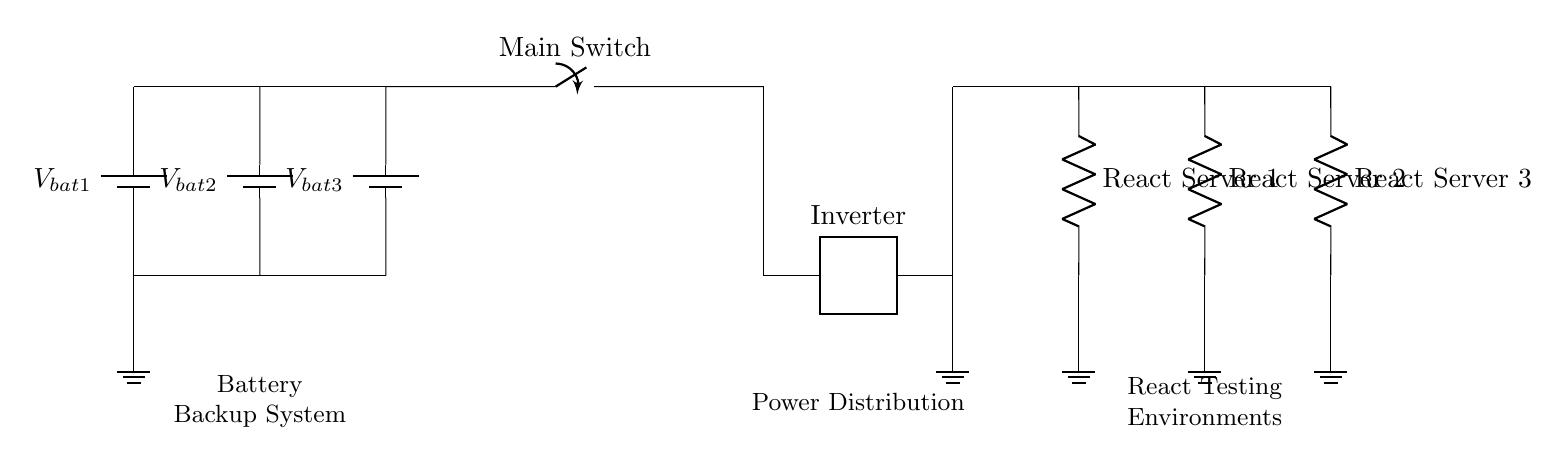What is the type of circuit shown? The circuit is a parallel circuit because the batteries are connected side-by-side, allowing multiple paths for current to flow.
Answer: Parallel circuit How many batteries are in the system? The circuit shows three batteries connected in parallel. Each battery is represented individually in the diagram.
Answer: Three What is the function of the inverter? The inverter converts the direct current from the batteries into alternating current, which is necessary for the server racks to operate, as they typically use AC power.
Answer: Converts DC to AC What is the role of the main switch? The main switch controls the flow of power from the battery backup system to the inverter, allowing the user to easily connect or disconnect power to the entire system.
Answer: Power control Which component represents the React server? The components labeled "React Server 1," "React Server 2," and "React Server 3" indicate the servers hosting the React testing environments in the circuit diagram.
Answer: React servers What happens if one battery fails? If one battery fails in a parallel configuration, the other batteries will continue to supply power since they are connected along different paths, maintaining the circuit's overall functionality.
Answer: Other batteries continue to supply power How is grounding achieved in this circuit? Grounding is achieved by connecting specific points in the circuit, such as the negative terminals of the batteries and the outputs of the servers, to a ground node to ensure safety and stabilize the voltage.
Answer: Ground connections 